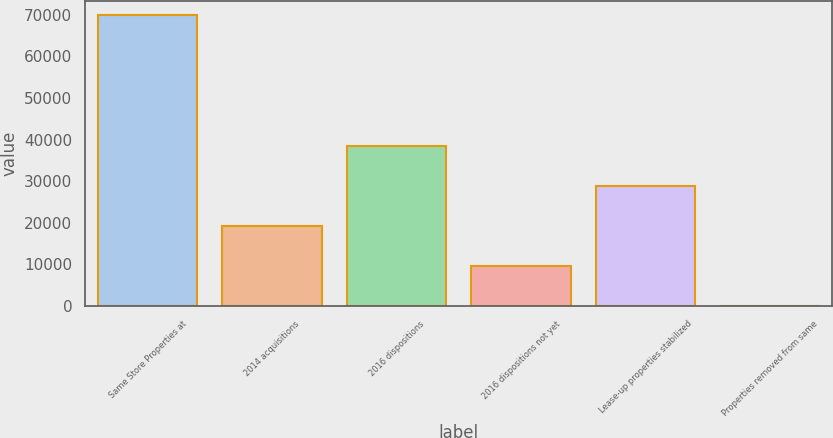Convert chart to OTSL. <chart><loc_0><loc_0><loc_500><loc_500><bar_chart><fcel>Same Store Properties at<fcel>2014 acquisitions<fcel>2016 dispositions<fcel>2016 dispositions not yet<fcel>Lease-up properties stabilized<fcel>Properties removed from same<nl><fcel>69879<fcel>19314<fcel>38557<fcel>9692.5<fcel>28935.5<fcel>71<nl></chart> 